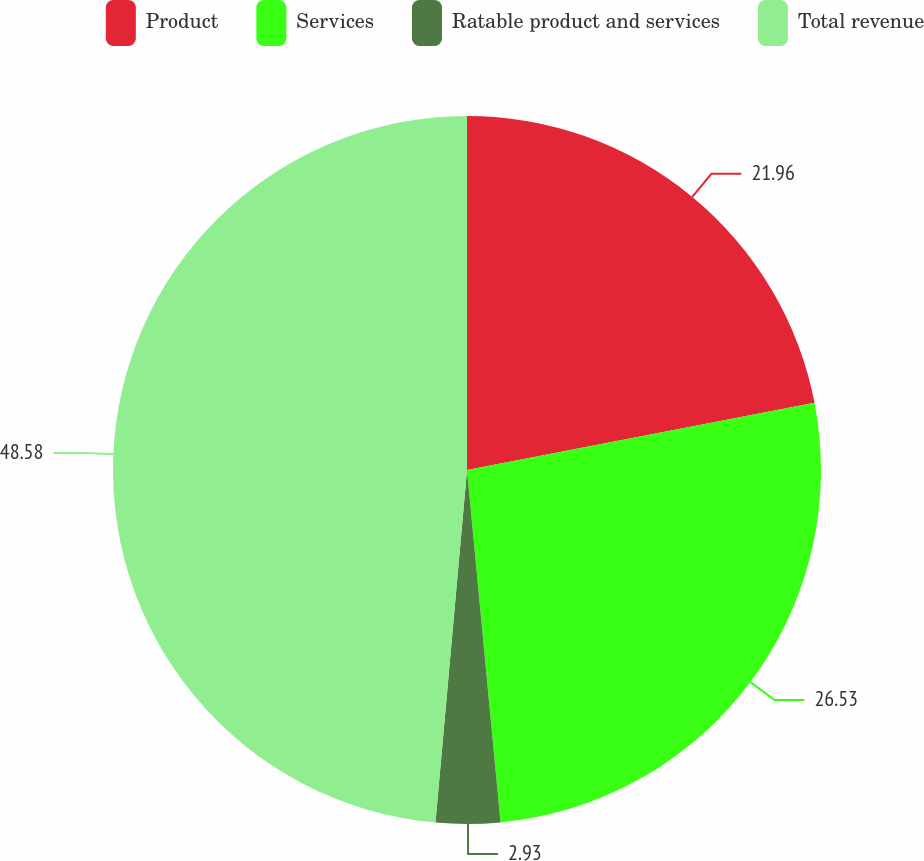Convert chart to OTSL. <chart><loc_0><loc_0><loc_500><loc_500><pie_chart><fcel>Product<fcel>Services<fcel>Ratable product and services<fcel>Total revenue<nl><fcel>21.96%<fcel>26.53%<fcel>2.93%<fcel>48.58%<nl></chart> 